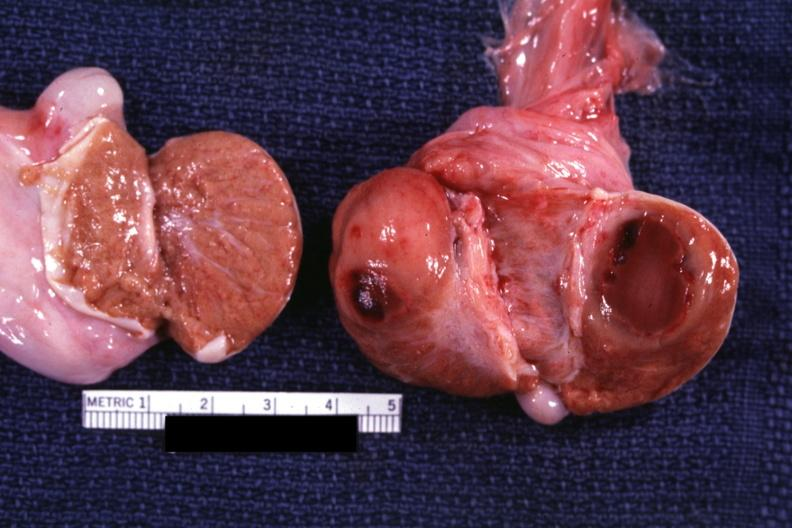what is present?
Answer the question using a single word or phrase. Testicle 